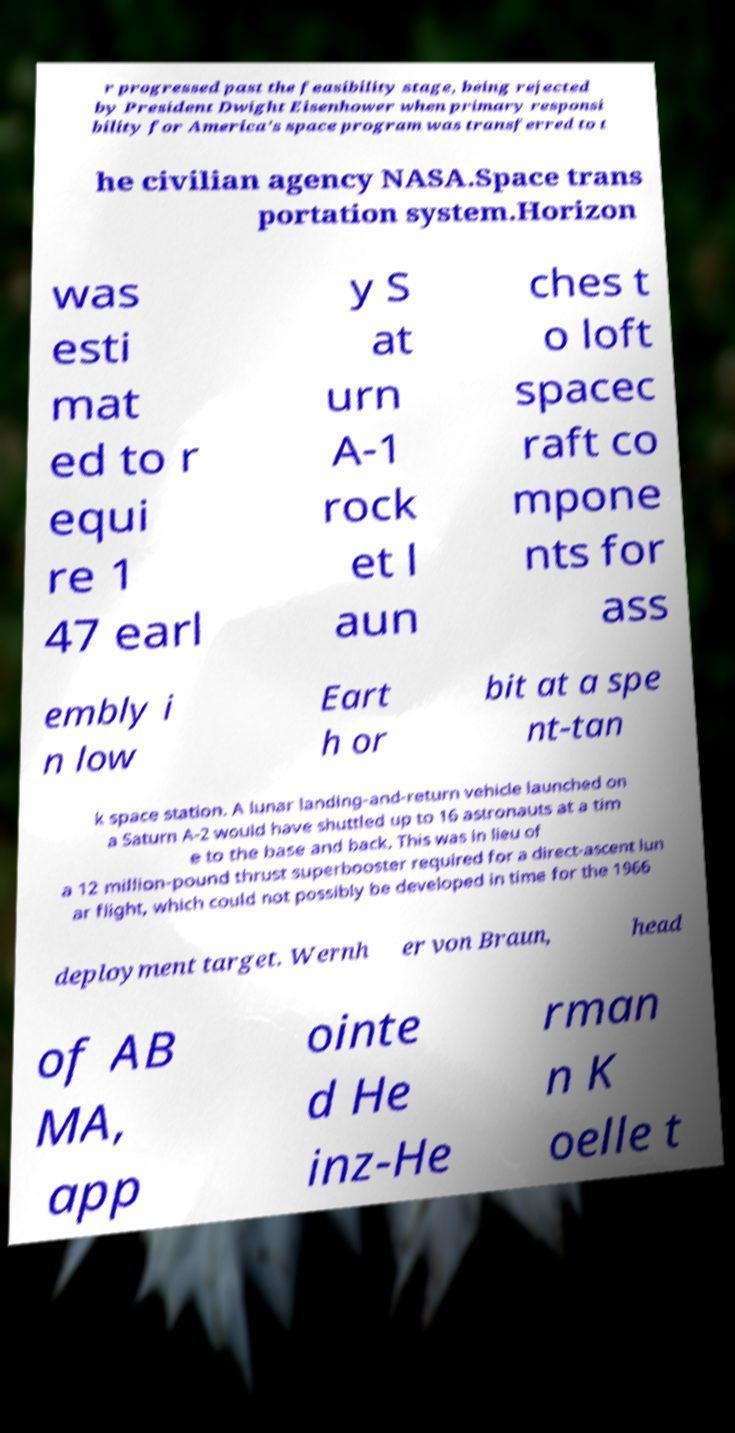Please read and relay the text visible in this image. What does it say? r progressed past the feasibility stage, being rejected by President Dwight Eisenhower when primary responsi bility for America's space program was transferred to t he civilian agency NASA.Space trans portation system.Horizon was esti mat ed to r equi re 1 47 earl y S at urn A-1 rock et l aun ches t o loft spacec raft co mpone nts for ass embly i n low Eart h or bit at a spe nt-tan k space station. A lunar landing-and-return vehicle launched on a Saturn A-2 would have shuttled up to 16 astronauts at a tim e to the base and back. This was in lieu of a 12 million-pound thrust superbooster required for a direct-ascent lun ar flight, which could not possibly be developed in time for the 1966 deployment target. Wernh er von Braun, head of AB MA, app ointe d He inz-He rman n K oelle t 